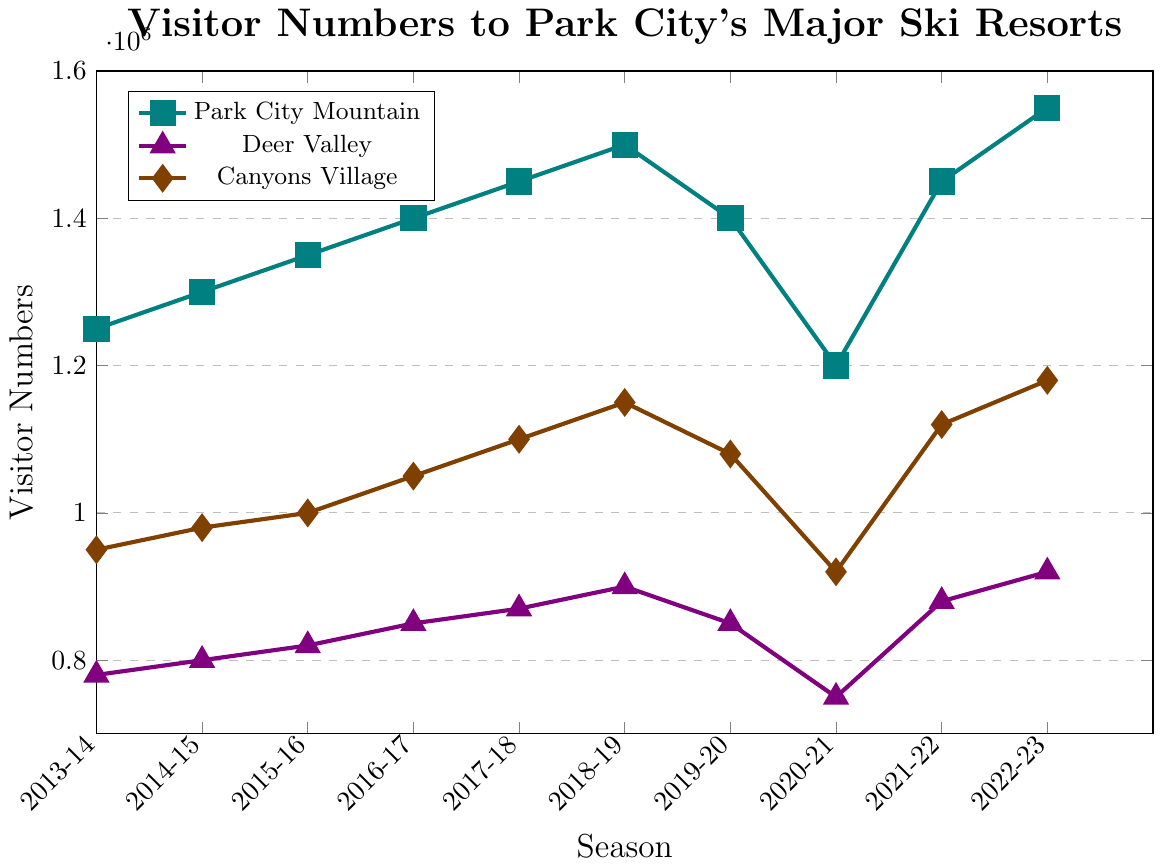What is the trend of visitor numbers for Park City Mountain over the last 10 winter seasons? The data shows a generally upward trend except for a dip in the 2019-2020 and 2020-2021 seasons. The numbers start at 1,250,000 in 2013-2014 and rise to 1,550,000 in 2022-2023.
Answer: Upward trend with a dip in 2019-2021 How did the visitor numbers for Deer Valley change from the 2018-2019 season to the 2019-2020 season? Deer Valley saw a decrease in visitor numbers. In 2018-2019, there were 900,000 visitors, which fell to 850,000 in 2019-2020.
Answer: Decreased by 50,000 Which resort had the highest number of visitors in the 2022-2023 season? The three resorts had the following visitor numbers in the 2022-2023 season: Park City Mountain had 1,550,000, Deer Valley had 920,000, and Canyons Village had 1,180,000. Comparing these, Park City Mountain had the highest number of visitors.
Answer: Park City Mountain By how much did the visitor numbers for Canyons Village change from the 2019-2020 season to the 2020-2021 season? The visitor numbers for Canyons Village were 1,080,000 in 2019-2020 and declined to 920,000 in 2020-2021. The change is calculated as 1,080,000 - 920,000, which equals 160,000.
Answer: Decreased by 160,000 Compare the visitor numbers for Deer Valley and Canyons Village in the 2015-2016 season. Which one had more visitors, and by how much? In the 2015-2016 season, Deer Valley had 820,000 visitors, and Canyons Village had 1,000,000. The difference in visitor numbers is 1,000,000 - 820,000, which equals 180,000.
Answer: Canyons Village by 180,000 What was the overall trend in visitor numbers for all resorts during the 2020-2021 season? All resorts saw a decrease in visitor numbers during the 2020-2021 season. Park City Mountain went from 1,400,000 to 1,200,000, Deer Valley from 850,000 to 750,000, and Canyons Village from 1,080,000 to 920,000.
Answer: Decreasing trend Which season experienced the lowest visitor numbers for Park City Mountain, and what were the figures? Park City Mountain experienced its lowest visitor numbers in the 2020-2021 season, with 1,200,000 visitors.
Answer: 2020-2021, 1,200,000 Find the average number of visitors for Deer Valley over the first three seasons (2013-2014 to 2015-2016). The visitor numbers for Deer Valley in the first three seasons are 780,000, 800,000, and 820,000. The average is calculated as (780,000 + 800,000 + 820,000) / 3 = 800,000.
Answer: 800,000 What is the visual difference between the trends for Canyons Village and Deer Valley over the ten seasons? Canyons Village's visitor numbers show a more pronounced increase and a larger fluctuation compared to Deer Valley's steadier rise with moderate fluctuations. This is noticeable in the sharper increases and decreases in the line for Canyons Village compared to the smoother line for Deer Valley.
Answer: Canyons Village has sharper fluctuations, Deer Valley has a steadier rise 